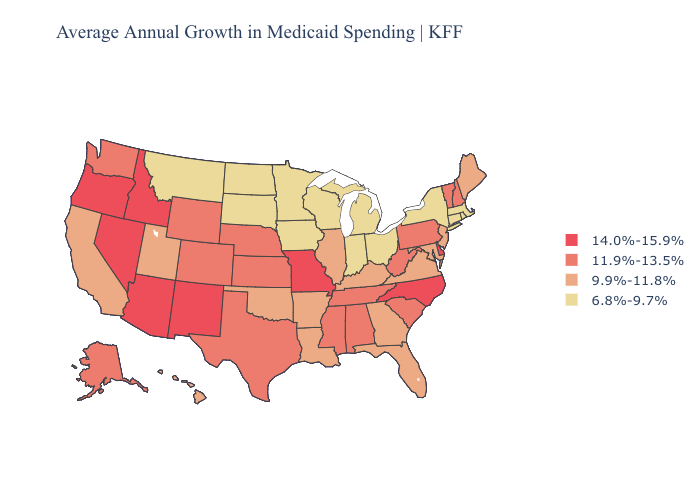What is the lowest value in states that border Arkansas?
Answer briefly. 9.9%-11.8%. Does the map have missing data?
Keep it brief. No. Does Wisconsin have a lower value than Montana?
Write a very short answer. No. What is the value of Virginia?
Answer briefly. 9.9%-11.8%. Does New Hampshire have the highest value in the Northeast?
Answer briefly. Yes. What is the highest value in states that border Pennsylvania?
Give a very brief answer. 14.0%-15.9%. Name the states that have a value in the range 6.8%-9.7%?
Concise answer only. Connecticut, Indiana, Iowa, Massachusetts, Michigan, Minnesota, Montana, New York, North Dakota, Ohio, Rhode Island, South Dakota, Wisconsin. What is the value of Louisiana?
Quick response, please. 9.9%-11.8%. Which states have the highest value in the USA?
Give a very brief answer. Arizona, Delaware, Idaho, Missouri, Nevada, New Mexico, North Carolina, Oregon. What is the value of Indiana?
Be succinct. 6.8%-9.7%. Name the states that have a value in the range 14.0%-15.9%?
Answer briefly. Arizona, Delaware, Idaho, Missouri, Nevada, New Mexico, North Carolina, Oregon. Does Hawaii have a higher value than New York?
Be succinct. Yes. Does the first symbol in the legend represent the smallest category?
Short answer required. No. Name the states that have a value in the range 14.0%-15.9%?
Concise answer only. Arizona, Delaware, Idaho, Missouri, Nevada, New Mexico, North Carolina, Oregon. Which states have the highest value in the USA?
Short answer required. Arizona, Delaware, Idaho, Missouri, Nevada, New Mexico, North Carolina, Oregon. 